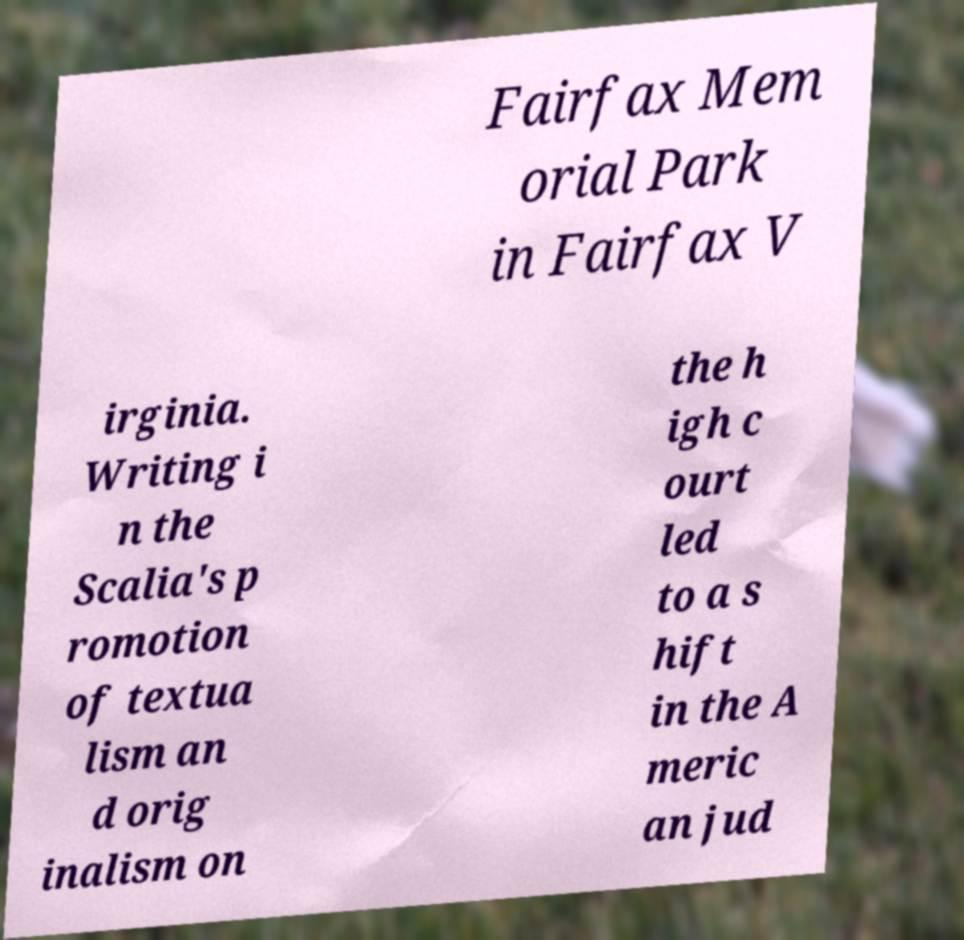Could you extract and type out the text from this image? Fairfax Mem orial Park in Fairfax V irginia. Writing i n the Scalia's p romotion of textua lism an d orig inalism on the h igh c ourt led to a s hift in the A meric an jud 